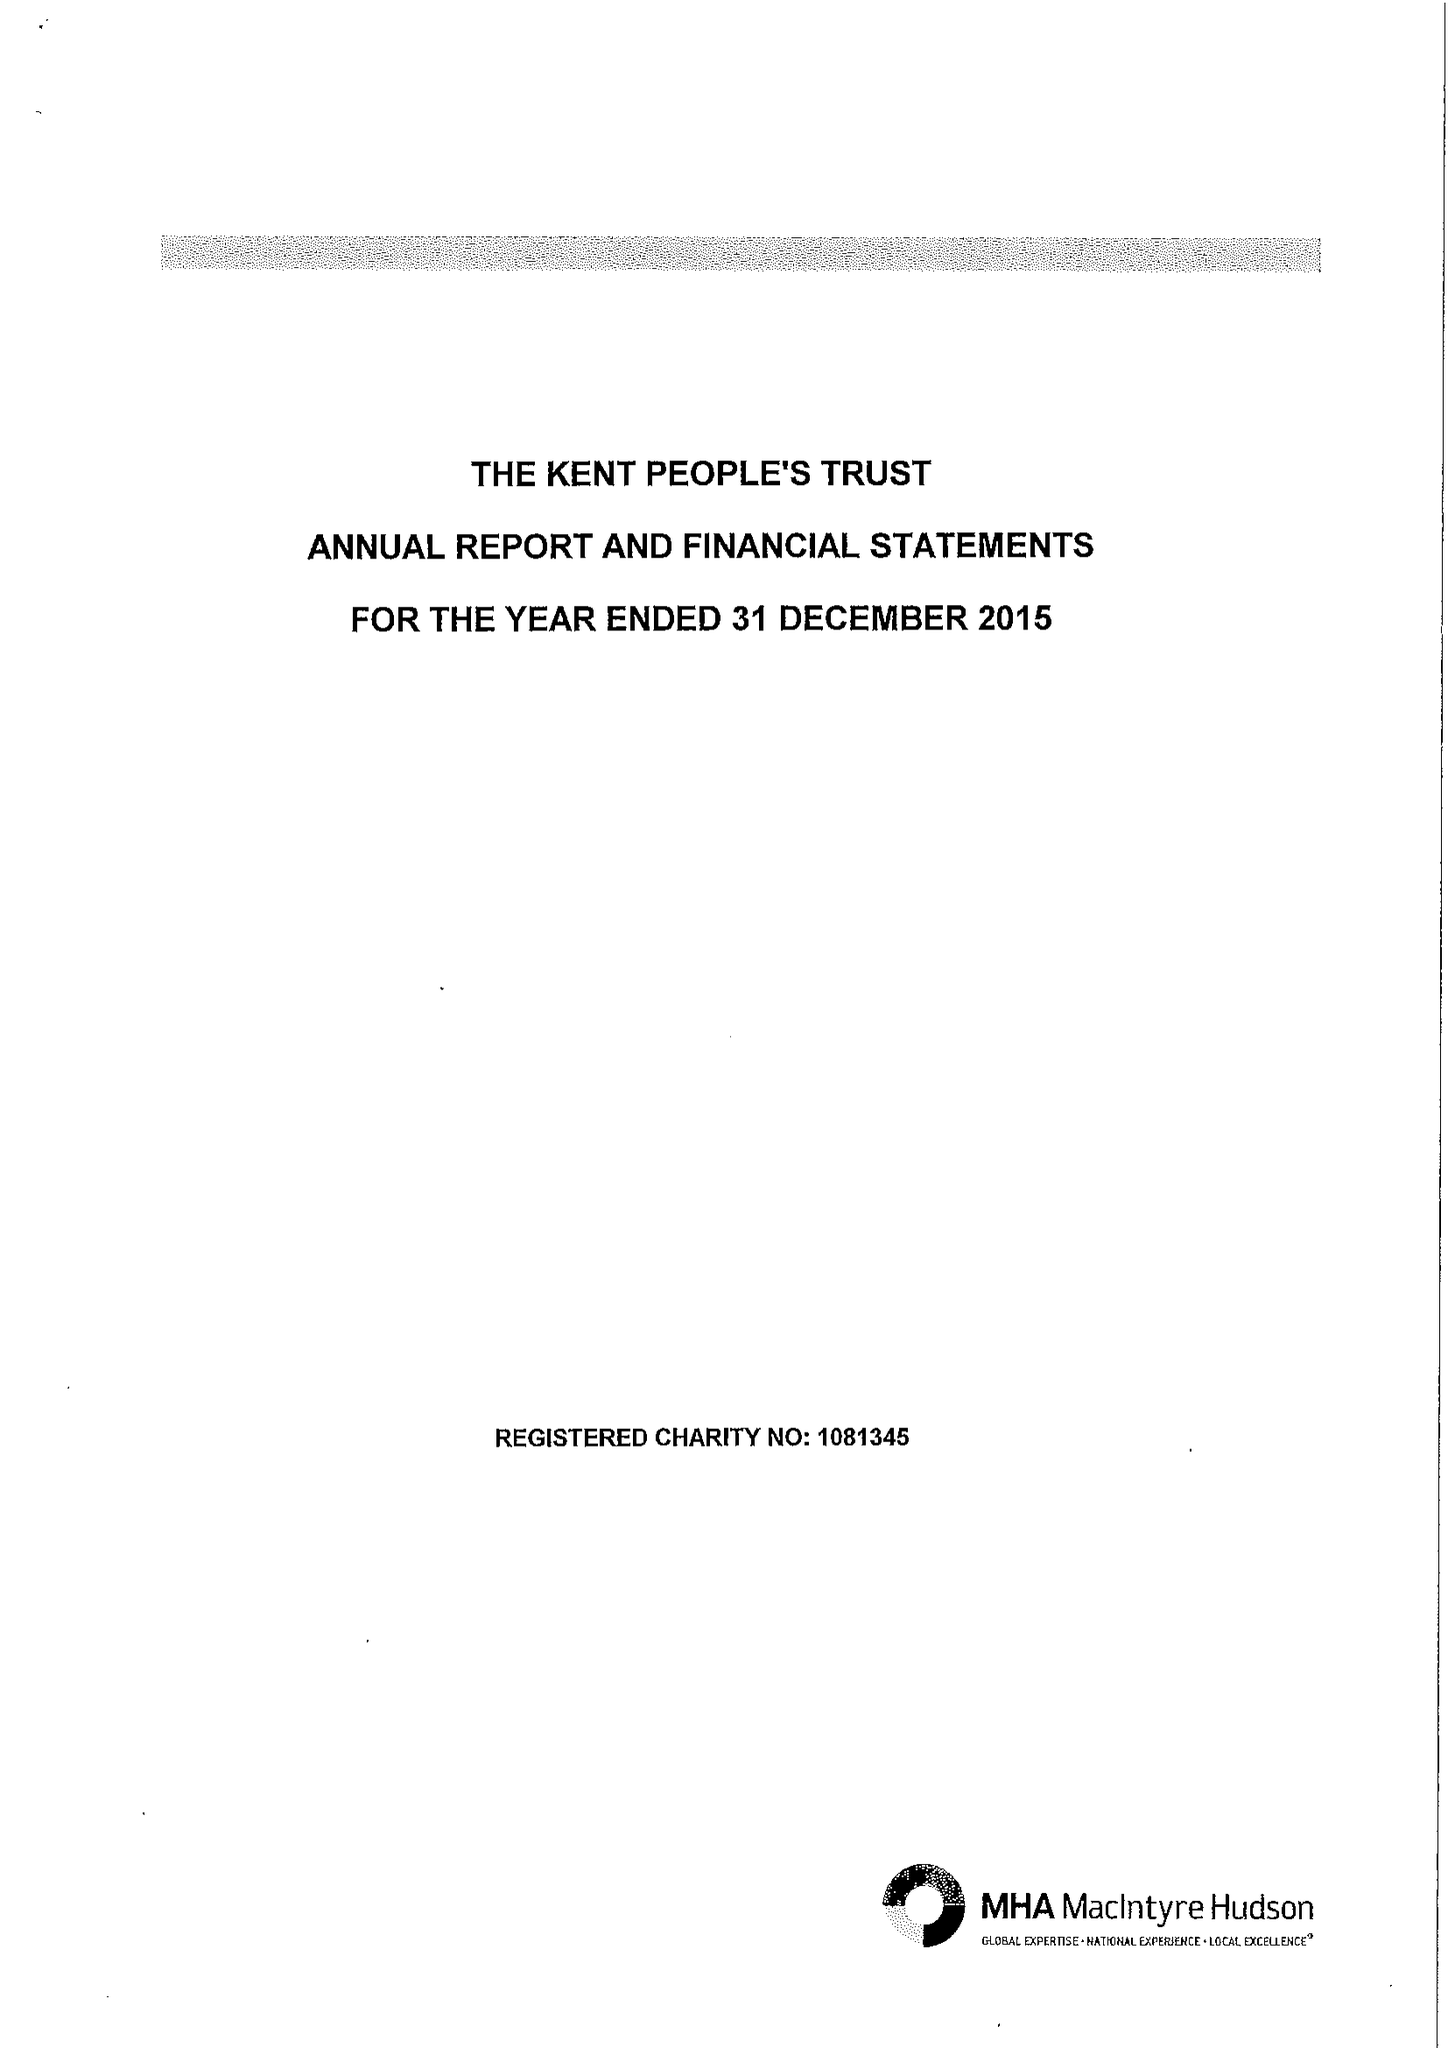What is the value for the address__street_line?
Answer the question using a single word or phrase. SUTTON ROAD 